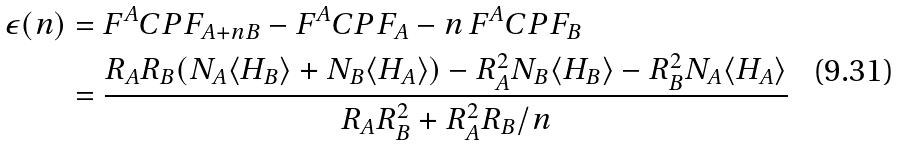<formula> <loc_0><loc_0><loc_500><loc_500>\epsilon ( n ) & = F ^ { A } C P F _ { A + n B } - F ^ { A } C P F _ { A } - n \, F ^ { A } C P F _ { B } \\ & = \frac { R _ { A } R _ { B } ( N _ { A } \langle H _ { B } \rangle + N _ { B } \langle H _ { A } \rangle ) - R _ { A } ^ { 2 } N _ { B } \langle H _ { B } \rangle - R _ { B } ^ { 2 } N _ { A } \langle H _ { A } \rangle } { R _ { A } R _ { B } ^ { 2 } + R _ { A } ^ { 2 } R _ { B } / n }</formula> 